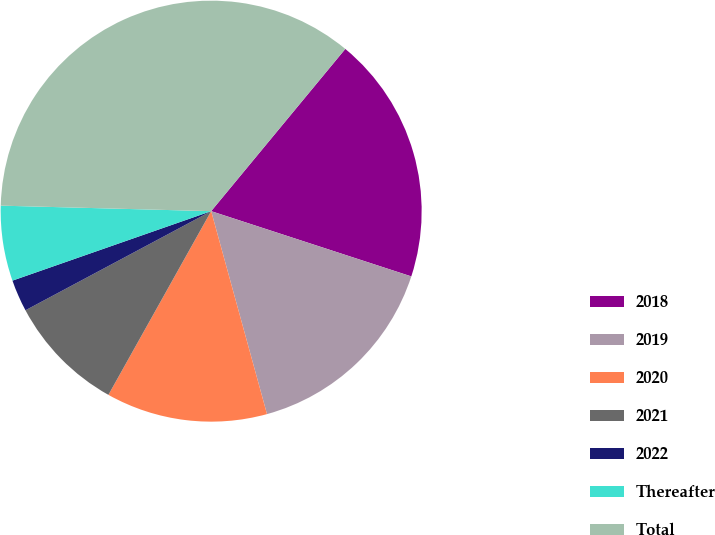Convert chart. <chart><loc_0><loc_0><loc_500><loc_500><pie_chart><fcel>2018<fcel>2019<fcel>2020<fcel>2021<fcel>2022<fcel>Thereafter<fcel>Total<nl><fcel>19.02%<fcel>15.71%<fcel>12.39%<fcel>9.08%<fcel>2.45%<fcel>5.77%<fcel>35.58%<nl></chart> 